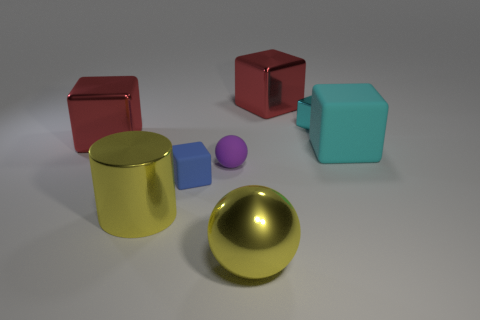Subtract all metal cubes. How many cubes are left? 2 Subtract 1 cylinders. How many cylinders are left? 0 Add 2 tiny shiny cubes. How many objects exist? 10 Subtract all blue blocks. How many blocks are left? 4 Subtract all blocks. How many objects are left? 3 Subtract all gray cylinders. How many red cubes are left? 2 Subtract all red metal cubes. Subtract all cyan metal cubes. How many objects are left? 5 Add 3 matte spheres. How many matte spheres are left? 4 Add 7 purple spheres. How many purple spheres exist? 8 Subtract 1 yellow spheres. How many objects are left? 7 